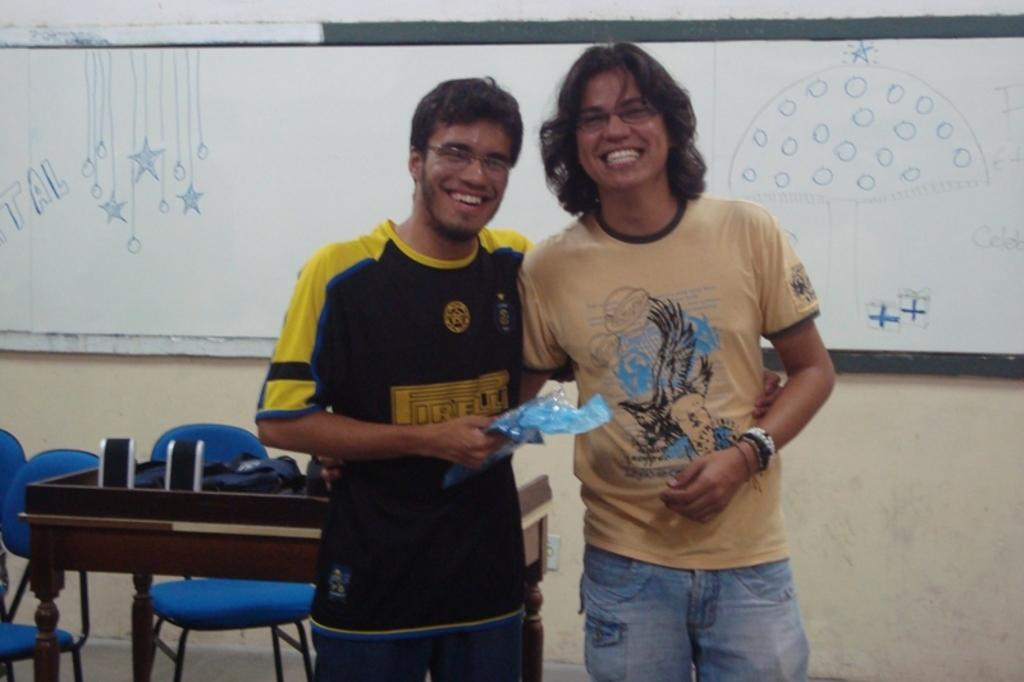How many people are in the image? There are two persons in the image. What are the persons doing in the image? The persons are standing and smiling. What can be seen on the wall in the image? There is a wall with a board in the image. What type of furniture is present in the image? There are chairs and a table in the image. What color is the brain of the person on the left in the image? There is no brain visible in the image, as it features two people standing and smiling. How many times does the person on the right sneeze in the image? There is no sneezing depicted in the image; the persons are simply standing and smiling. 